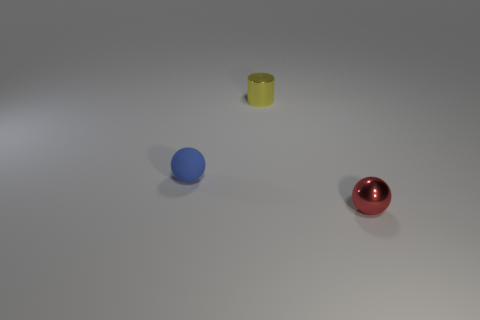How big is the blue matte thing?
Your answer should be very brief. Small. Are the tiny object that is right of the yellow thing and the tiny yellow cylinder made of the same material?
Provide a succinct answer. Yes. There is another matte object that is the same shape as the red object; what color is it?
Your answer should be compact. Blue. There is a tiny rubber sphere; are there any tiny blue matte objects in front of it?
Make the answer very short. No. There is a small thing that is both in front of the small yellow cylinder and on the right side of the small blue object; what color is it?
Keep it short and to the point. Red. What size is the thing that is in front of the object that is to the left of the metal cylinder?
Give a very brief answer. Small. How many blocks are either large yellow metallic objects or tiny rubber objects?
Offer a very short reply. 0. The metal cylinder that is the same size as the red thing is what color?
Offer a terse response. Yellow. The tiny metal thing left of the metallic object that is in front of the tiny blue ball is what shape?
Give a very brief answer. Cylinder. How many other things are the same material as the cylinder?
Make the answer very short. 1. 